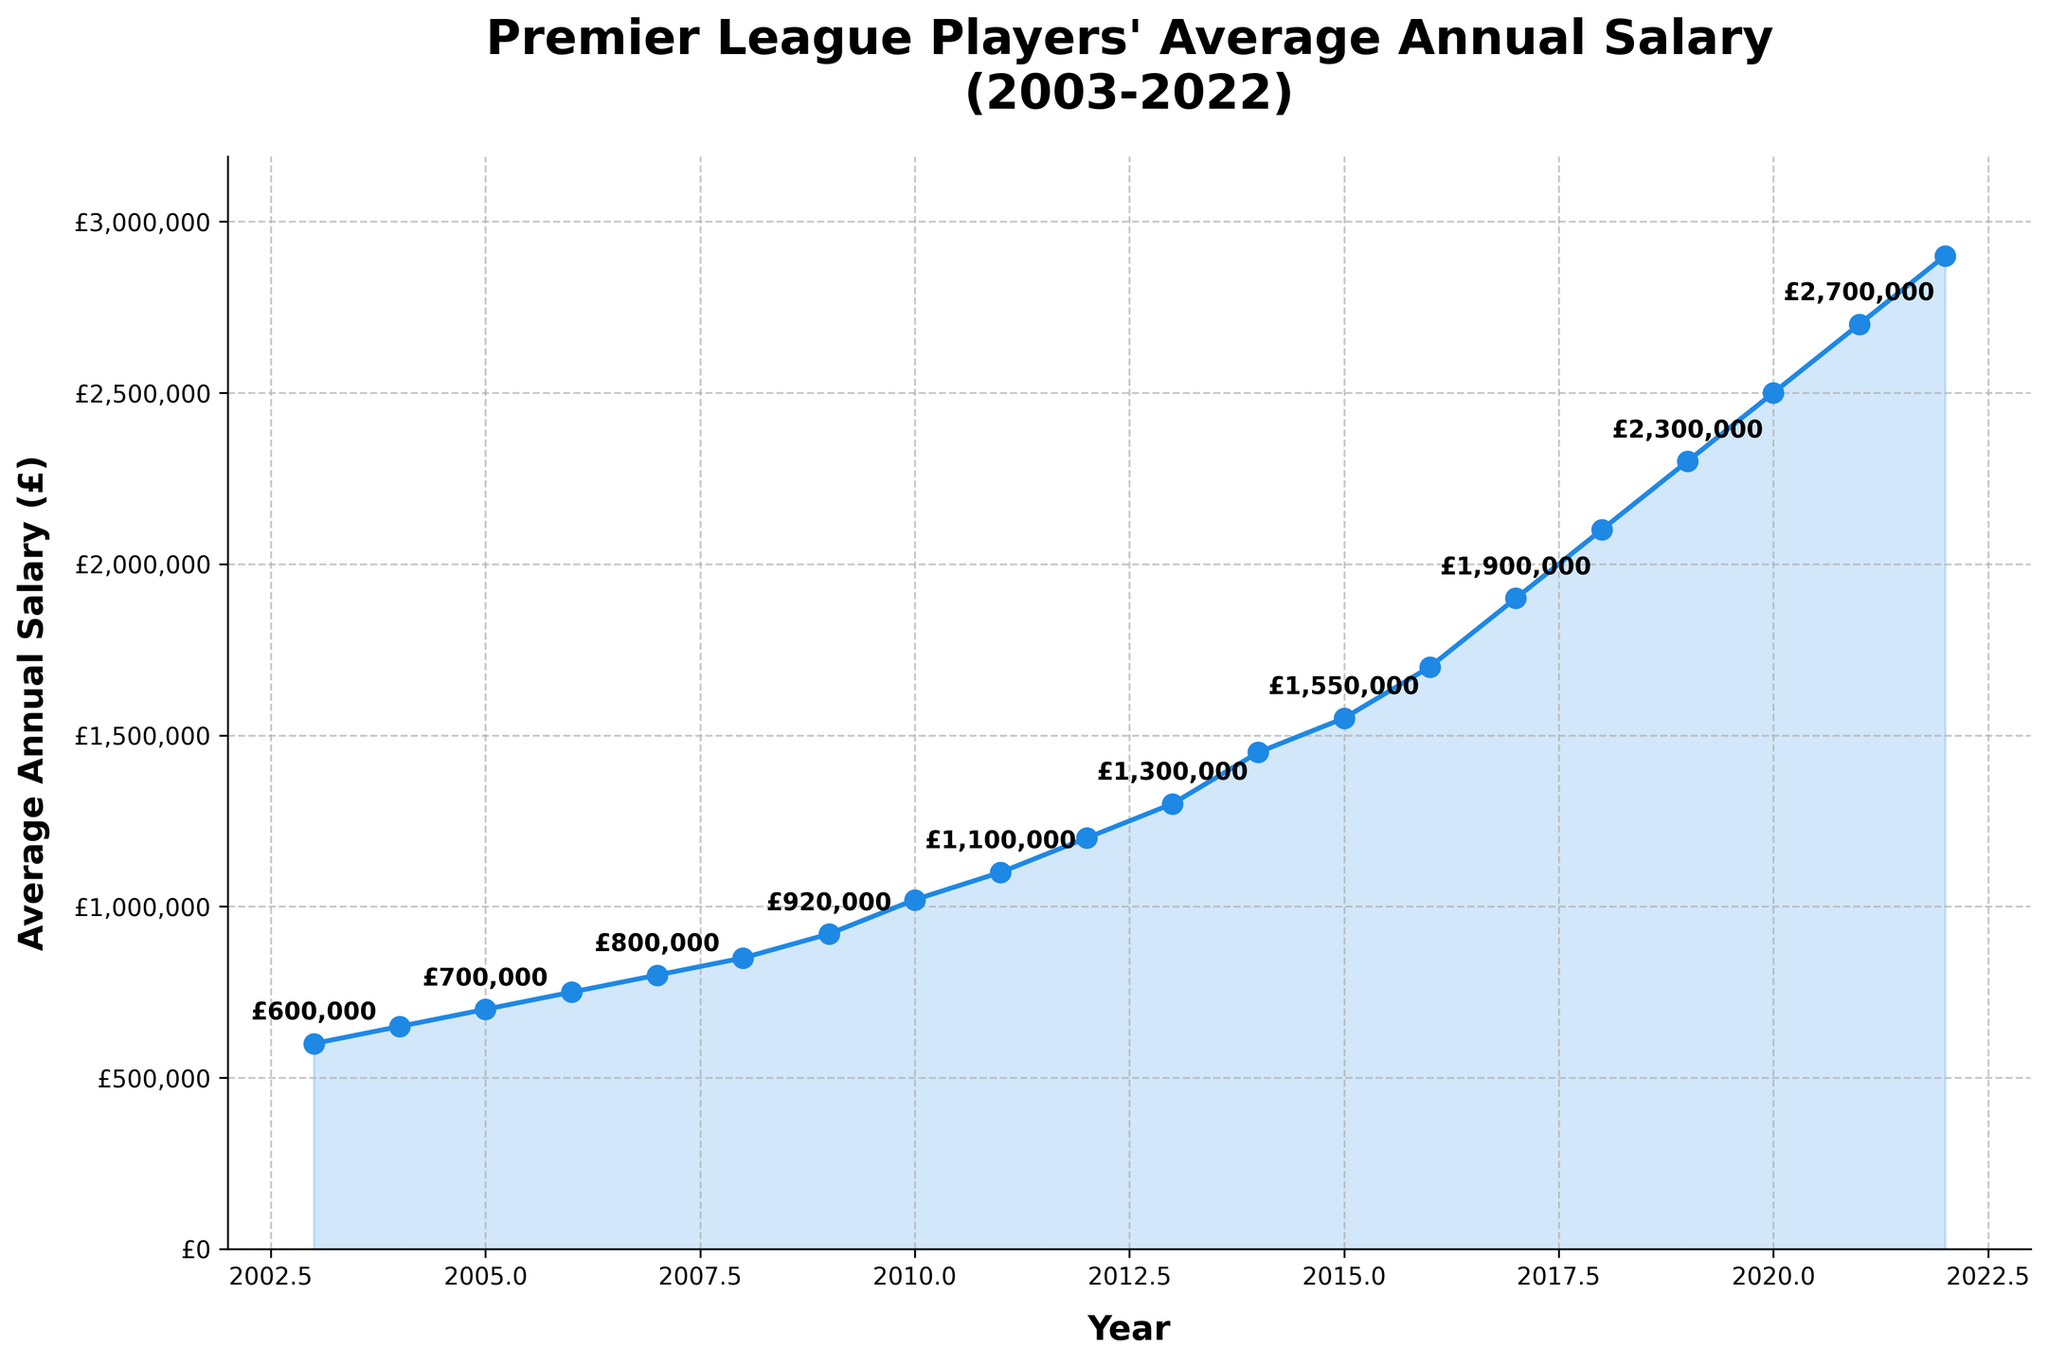What's the title of the plot? The title is given at the top of the plot, and it describes what the plot represents.
Answer: Premier League Players' Average Annual Salary (2003-2022) What is the y-axis label in the plot? The y-axis label is located vertically on the left side of the plot and indicates what is being measured.
Answer: Average Annual Salary (£) What is the x-axis range for the plot? The x-axis range can be determined by looking at the minimum and maximum values on the horizontal axis. The data points start from 2003 and go until 2022, with an axis limit slightly beyond these years.
Answer: 2002 to 2023 Around what year did the average annual salary exceed £1,000,000? Find the point at which the plotted line crosses the £1,000,000 mark on the y-axis.
Answer: Around 2010 How much higher was the average annual salary in 2022 compared to 2003? Subtract the salary in 2003 from the salary in 2022. £2,900,000 - £600,000 = £2,300,000
Answer: £2,300,000 What is the approximate average trend of the salary increase per year? Subtract the starting value (2003) from the ending value (2022) and divide by the number of years. (£2,900,000 - £600,000) / (2022 - 2003) = £2,300,000 / 19 years ≈ £121,052.63
Answer: ≈ £121,052.63 per year In which year did the average annual salary see the most significant increase? Compare the salary increases year-by-year by subtracting the previous year's salary from the current year's salary and identify the largest increase.
Answer: 2010 By how much did the average annual salary increase from 2014 to 2015? Subtract the salary in 2014 from the salary in 2015. £1,550,000 - £1,450,000 = £100,000
Answer: £100,000 